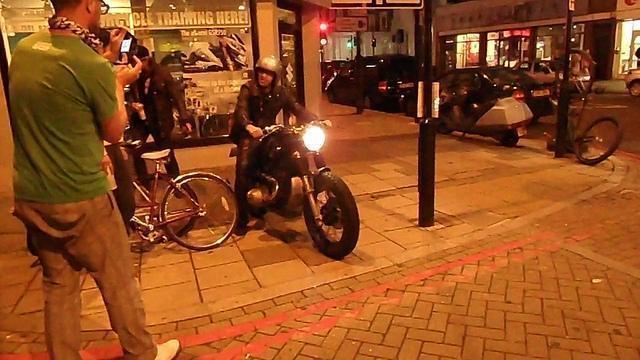What is aimed at the man on the motorcycle?
Indicate the correct choice and explain in the format: 'Answer: answer
Rationale: rationale.'
Options: Camera, antique blunderbuss, paintball, ruler. Answer: camera.
Rationale: There is a camera aimed at the man driving the motorcycle. 